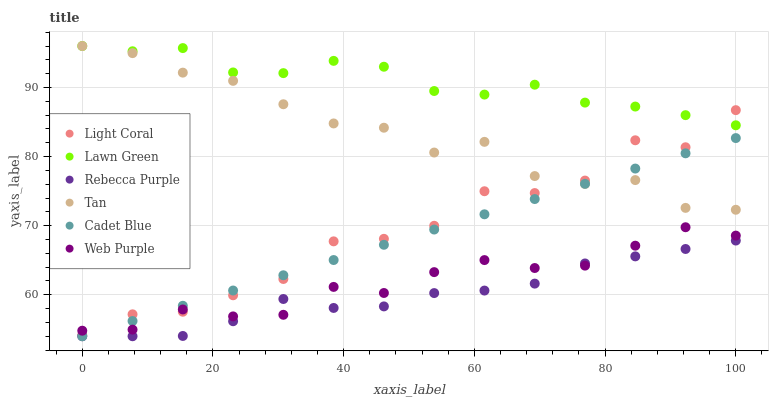Does Rebecca Purple have the minimum area under the curve?
Answer yes or no. Yes. Does Lawn Green have the maximum area under the curve?
Answer yes or no. Yes. Does Cadet Blue have the minimum area under the curve?
Answer yes or no. No. Does Cadet Blue have the maximum area under the curve?
Answer yes or no. No. Is Cadet Blue the smoothest?
Answer yes or no. Yes. Is Light Coral the roughest?
Answer yes or no. Yes. Is Light Coral the smoothest?
Answer yes or no. No. Is Cadet Blue the roughest?
Answer yes or no. No. Does Cadet Blue have the lowest value?
Answer yes or no. Yes. Does Light Coral have the lowest value?
Answer yes or no. No. Does Tan have the highest value?
Answer yes or no. Yes. Does Cadet Blue have the highest value?
Answer yes or no. No. Is Rebecca Purple less than Tan?
Answer yes or no. Yes. Is Lawn Green greater than Rebecca Purple?
Answer yes or no. Yes. Does Tan intersect Light Coral?
Answer yes or no. Yes. Is Tan less than Light Coral?
Answer yes or no. No. Is Tan greater than Light Coral?
Answer yes or no. No. Does Rebecca Purple intersect Tan?
Answer yes or no. No. 